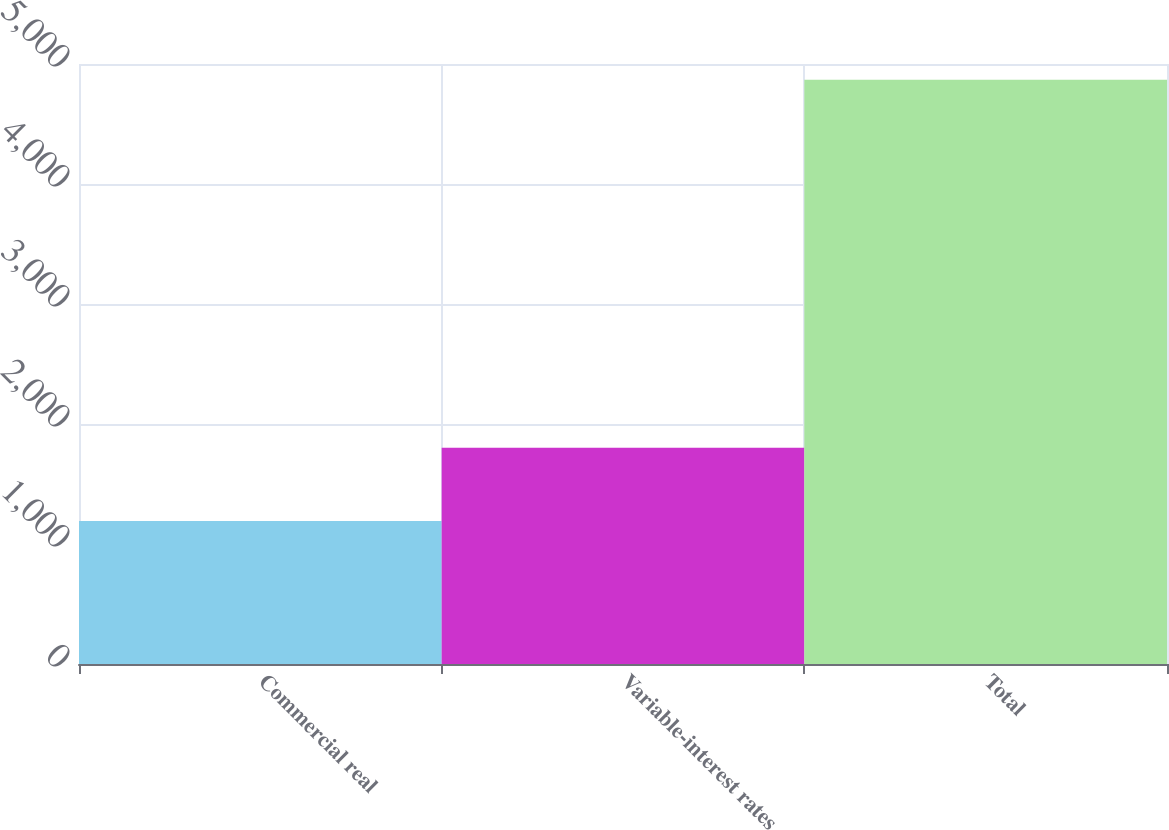Convert chart. <chart><loc_0><loc_0><loc_500><loc_500><bar_chart><fcel>Commercial real<fcel>Variable-interest rates<fcel>Total<nl><fcel>1191<fcel>1802<fcel>4868<nl></chart> 